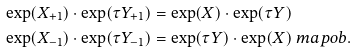<formula> <loc_0><loc_0><loc_500><loc_500>\exp ( X _ { + 1 } ) \cdot \exp ( \tau Y _ { + 1 } ) & = \exp ( X ) \cdot \exp ( \tau Y ) \\ \exp ( X _ { - 1 } ) \cdot \exp ( \tau Y _ { - 1 } ) & = \exp ( \tau Y ) \cdot \exp ( X ) \ m a p o b .</formula> 